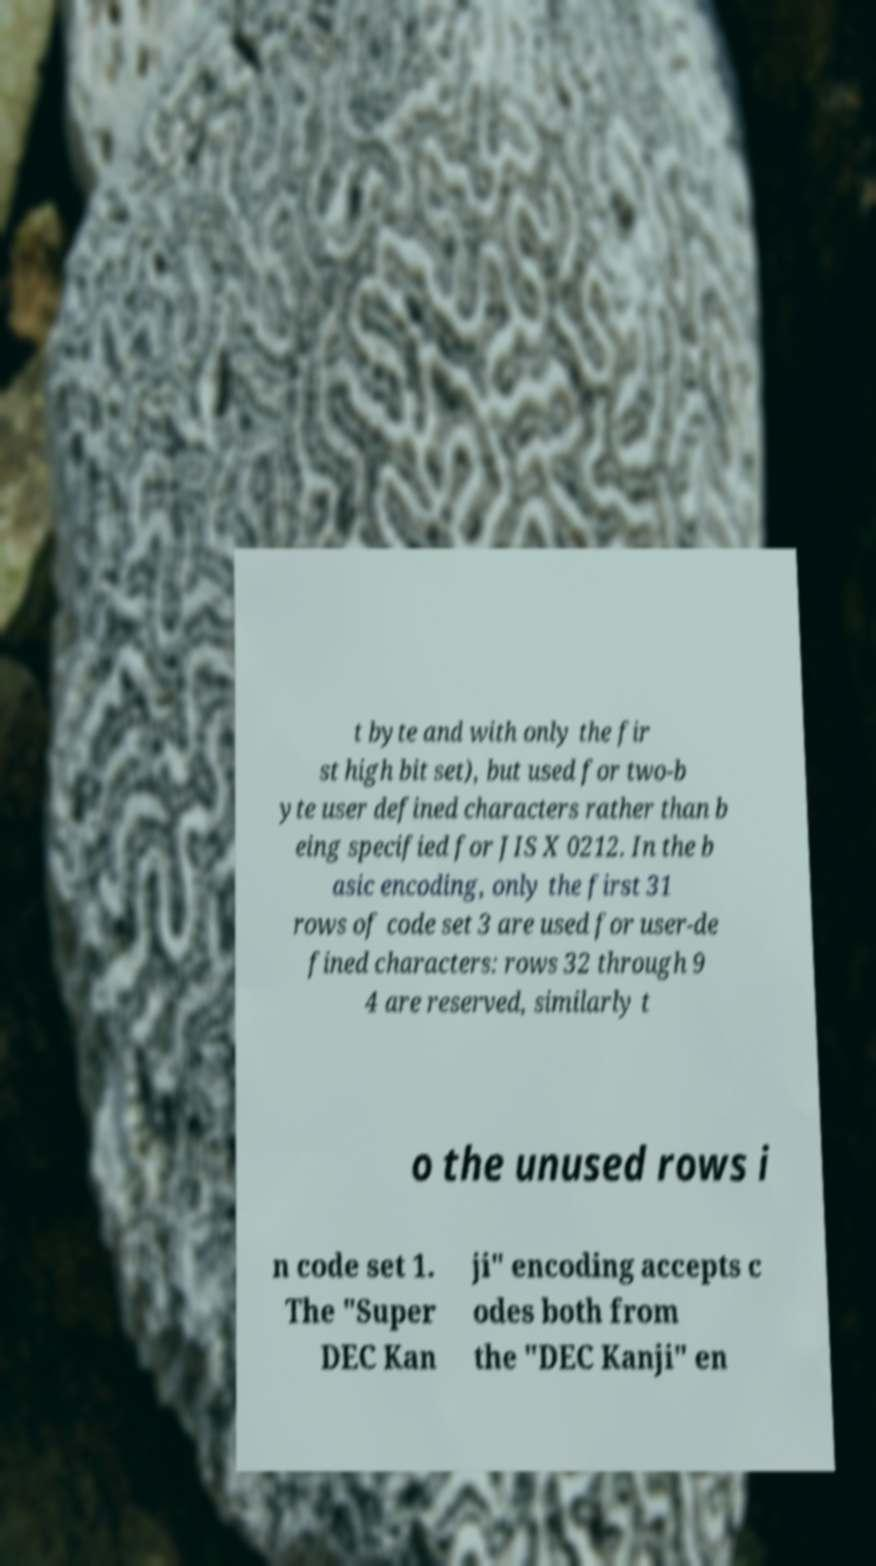I need the written content from this picture converted into text. Can you do that? t byte and with only the fir st high bit set), but used for two-b yte user defined characters rather than b eing specified for JIS X 0212. In the b asic encoding, only the first 31 rows of code set 3 are used for user-de fined characters: rows 32 through 9 4 are reserved, similarly t o the unused rows i n code set 1. The "Super DEC Kan ji" encoding accepts c odes both from the "DEC Kanji" en 